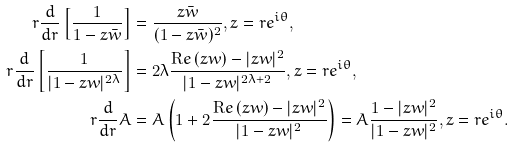<formula> <loc_0><loc_0><loc_500><loc_500>r \frac { d } { d r } \left [ \frac { 1 } { 1 - z \bar { w } } \right ] & = \frac { z \bar { w } } { ( 1 - z \bar { w } ) ^ { 2 } } , z = r e ^ { i \theta } , \\ r \frac { d } { d r } \left [ \frac { 1 } { | 1 - z w | ^ { 2 \lambda } } \right ] & = 2 \lambda \frac { { \mathrm R e } \, ( z w ) - | z w | ^ { 2 } } { | 1 - z w | ^ { 2 \lambda + 2 } } , z = r e ^ { i \theta } , \\ r \frac { d } { d r } A & = A \left ( 1 + 2 \frac { { \mathrm R e } \, ( z w ) - | z w | ^ { 2 } } { | 1 - z w | ^ { 2 } } \right ) = A \frac { 1 - | z w | ^ { 2 } } { | 1 - z w | ^ { 2 } } , z = r e ^ { i \theta } .</formula> 